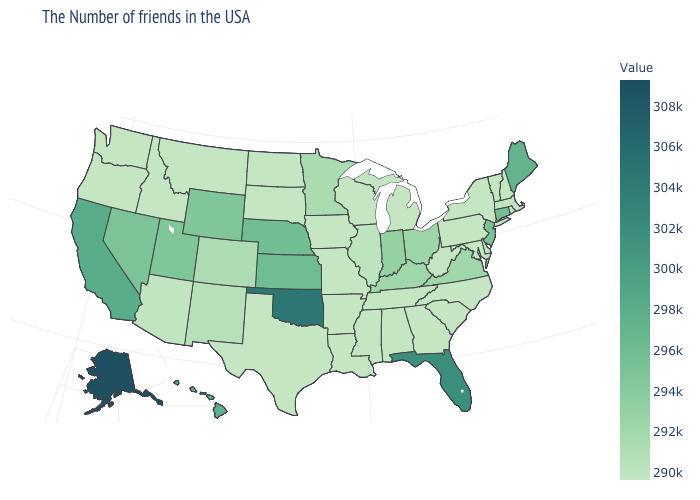Among the states that border Nebraska , does Missouri have the lowest value?
Keep it brief. Yes. Among the states that border Mississippi , which have the highest value?
Answer briefly. Alabama, Tennessee, Louisiana, Arkansas. Does the map have missing data?
Write a very short answer. No. Does Pennsylvania have the lowest value in the Northeast?
Concise answer only. Yes. Is the legend a continuous bar?
Be succinct. Yes. Among the states that border Arkansas , which have the highest value?
Give a very brief answer. Oklahoma. Which states hav the highest value in the West?
Short answer required. Alaska. 